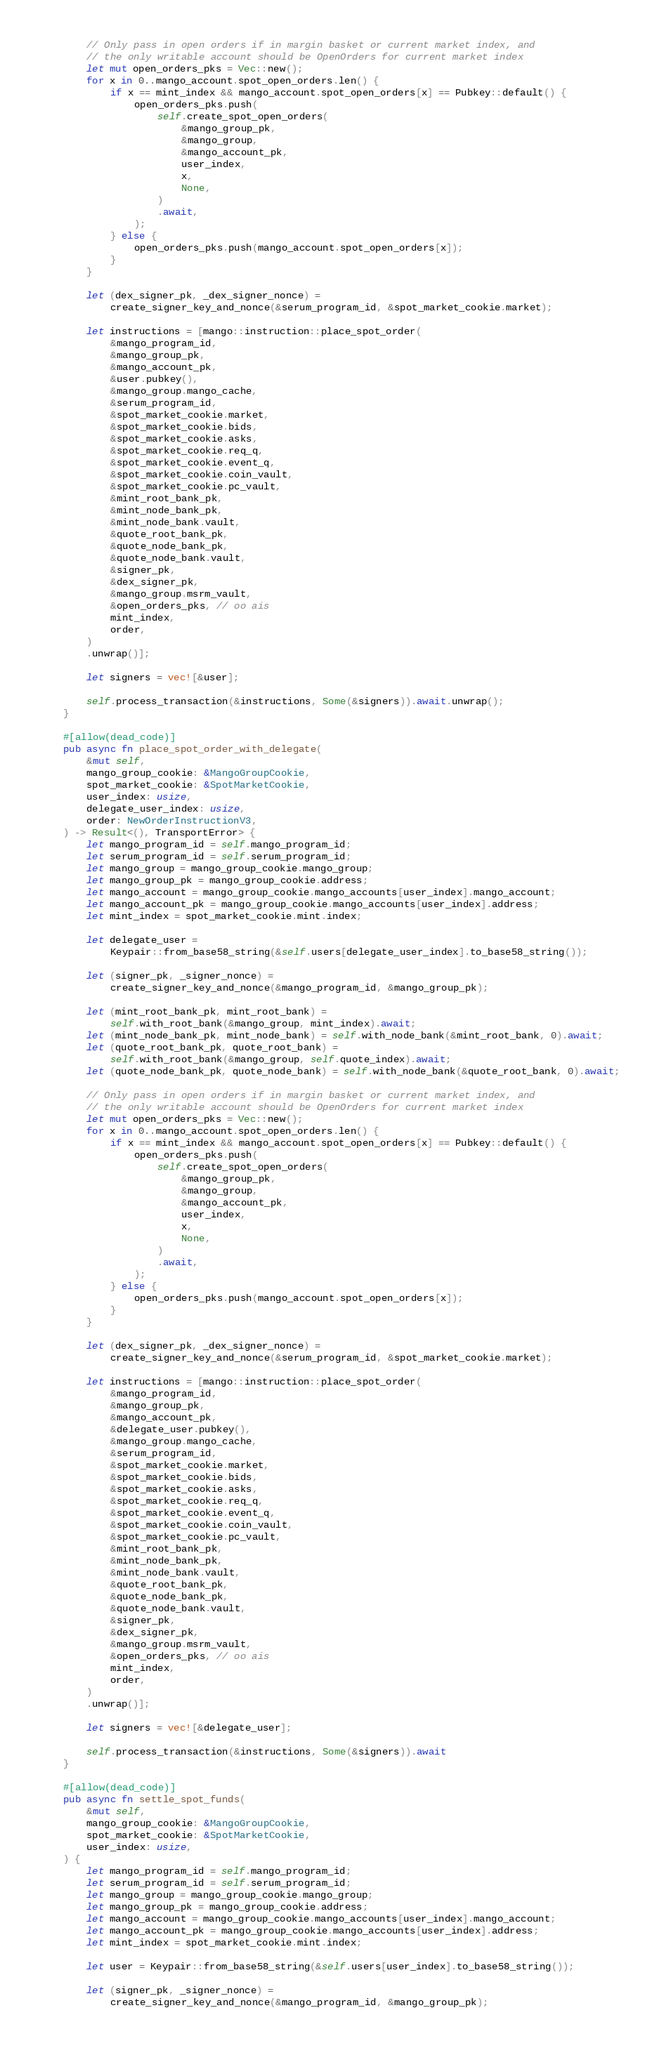Convert code to text. <code><loc_0><loc_0><loc_500><loc_500><_Rust_>        // Only pass in open orders if in margin basket or current market index, and
        // the only writable account should be OpenOrders for current market index
        let mut open_orders_pks = Vec::new();
        for x in 0..mango_account.spot_open_orders.len() {
            if x == mint_index && mango_account.spot_open_orders[x] == Pubkey::default() {
                open_orders_pks.push(
                    self.create_spot_open_orders(
                        &mango_group_pk,
                        &mango_group,
                        &mango_account_pk,
                        user_index,
                        x,
                        None,
                    )
                    .await,
                );
            } else {
                open_orders_pks.push(mango_account.spot_open_orders[x]);
            }
        }

        let (dex_signer_pk, _dex_signer_nonce) =
            create_signer_key_and_nonce(&serum_program_id, &spot_market_cookie.market);

        let instructions = [mango::instruction::place_spot_order(
            &mango_program_id,
            &mango_group_pk,
            &mango_account_pk,
            &user.pubkey(),
            &mango_group.mango_cache,
            &serum_program_id,
            &spot_market_cookie.market,
            &spot_market_cookie.bids,
            &spot_market_cookie.asks,
            &spot_market_cookie.req_q,
            &spot_market_cookie.event_q,
            &spot_market_cookie.coin_vault,
            &spot_market_cookie.pc_vault,
            &mint_root_bank_pk,
            &mint_node_bank_pk,
            &mint_node_bank.vault,
            &quote_root_bank_pk,
            &quote_node_bank_pk,
            &quote_node_bank.vault,
            &signer_pk,
            &dex_signer_pk,
            &mango_group.msrm_vault,
            &open_orders_pks, // oo ais
            mint_index,
            order,
        )
        .unwrap()];

        let signers = vec![&user];

        self.process_transaction(&instructions, Some(&signers)).await.unwrap();
    }

    #[allow(dead_code)]
    pub async fn place_spot_order_with_delegate(
        &mut self,
        mango_group_cookie: &MangoGroupCookie,
        spot_market_cookie: &SpotMarketCookie,
        user_index: usize,
        delegate_user_index: usize,
        order: NewOrderInstructionV3,
    ) -> Result<(), TransportError> {
        let mango_program_id = self.mango_program_id;
        let serum_program_id = self.serum_program_id;
        let mango_group = mango_group_cookie.mango_group;
        let mango_group_pk = mango_group_cookie.address;
        let mango_account = mango_group_cookie.mango_accounts[user_index].mango_account;
        let mango_account_pk = mango_group_cookie.mango_accounts[user_index].address;
        let mint_index = spot_market_cookie.mint.index;

        let delegate_user =
            Keypair::from_base58_string(&self.users[delegate_user_index].to_base58_string());

        let (signer_pk, _signer_nonce) =
            create_signer_key_and_nonce(&mango_program_id, &mango_group_pk);

        let (mint_root_bank_pk, mint_root_bank) =
            self.with_root_bank(&mango_group, mint_index).await;
        let (mint_node_bank_pk, mint_node_bank) = self.with_node_bank(&mint_root_bank, 0).await;
        let (quote_root_bank_pk, quote_root_bank) =
            self.with_root_bank(&mango_group, self.quote_index).await;
        let (quote_node_bank_pk, quote_node_bank) = self.with_node_bank(&quote_root_bank, 0).await;

        // Only pass in open orders if in margin basket or current market index, and
        // the only writable account should be OpenOrders for current market index
        let mut open_orders_pks = Vec::new();
        for x in 0..mango_account.spot_open_orders.len() {
            if x == mint_index && mango_account.spot_open_orders[x] == Pubkey::default() {
                open_orders_pks.push(
                    self.create_spot_open_orders(
                        &mango_group_pk,
                        &mango_group,
                        &mango_account_pk,
                        user_index,
                        x,
                        None,
                    )
                    .await,
                );
            } else {
                open_orders_pks.push(mango_account.spot_open_orders[x]);
            }
        }

        let (dex_signer_pk, _dex_signer_nonce) =
            create_signer_key_and_nonce(&serum_program_id, &spot_market_cookie.market);

        let instructions = [mango::instruction::place_spot_order(
            &mango_program_id,
            &mango_group_pk,
            &mango_account_pk,
            &delegate_user.pubkey(),
            &mango_group.mango_cache,
            &serum_program_id,
            &spot_market_cookie.market,
            &spot_market_cookie.bids,
            &spot_market_cookie.asks,
            &spot_market_cookie.req_q,
            &spot_market_cookie.event_q,
            &spot_market_cookie.coin_vault,
            &spot_market_cookie.pc_vault,
            &mint_root_bank_pk,
            &mint_node_bank_pk,
            &mint_node_bank.vault,
            &quote_root_bank_pk,
            &quote_node_bank_pk,
            &quote_node_bank.vault,
            &signer_pk,
            &dex_signer_pk,
            &mango_group.msrm_vault,
            &open_orders_pks, // oo ais
            mint_index,
            order,
        )
        .unwrap()];

        let signers = vec![&delegate_user];

        self.process_transaction(&instructions, Some(&signers)).await
    }

    #[allow(dead_code)]
    pub async fn settle_spot_funds(
        &mut self,
        mango_group_cookie: &MangoGroupCookie,
        spot_market_cookie: &SpotMarketCookie,
        user_index: usize,
    ) {
        let mango_program_id = self.mango_program_id;
        let serum_program_id = self.serum_program_id;
        let mango_group = mango_group_cookie.mango_group;
        let mango_group_pk = mango_group_cookie.address;
        let mango_account = mango_group_cookie.mango_accounts[user_index].mango_account;
        let mango_account_pk = mango_group_cookie.mango_accounts[user_index].address;
        let mint_index = spot_market_cookie.mint.index;

        let user = Keypair::from_base58_string(&self.users[user_index].to_base58_string());

        let (signer_pk, _signer_nonce) =
            create_signer_key_and_nonce(&mango_program_id, &mango_group_pk);
</code> 